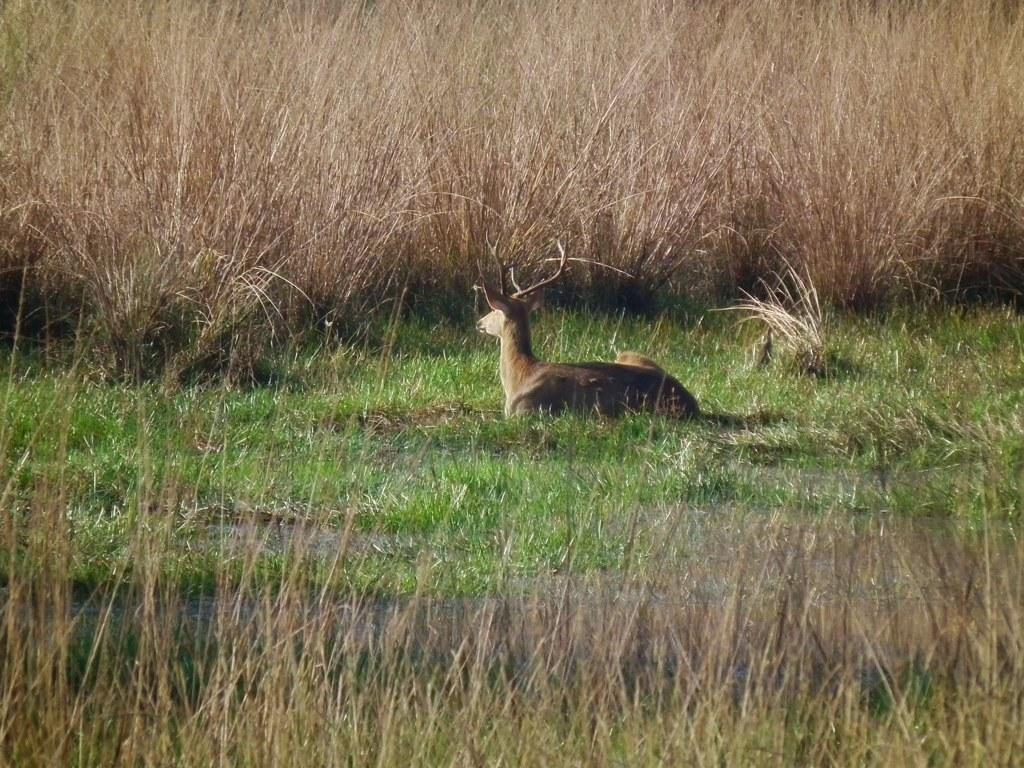In one or two sentences, can you explain what this image depicts? In this picture, we see a deer is sitting on the grass. At the bottom, we see the grass. In the background, there are trees. This picture might be clicked in the forest or in a zoo. 